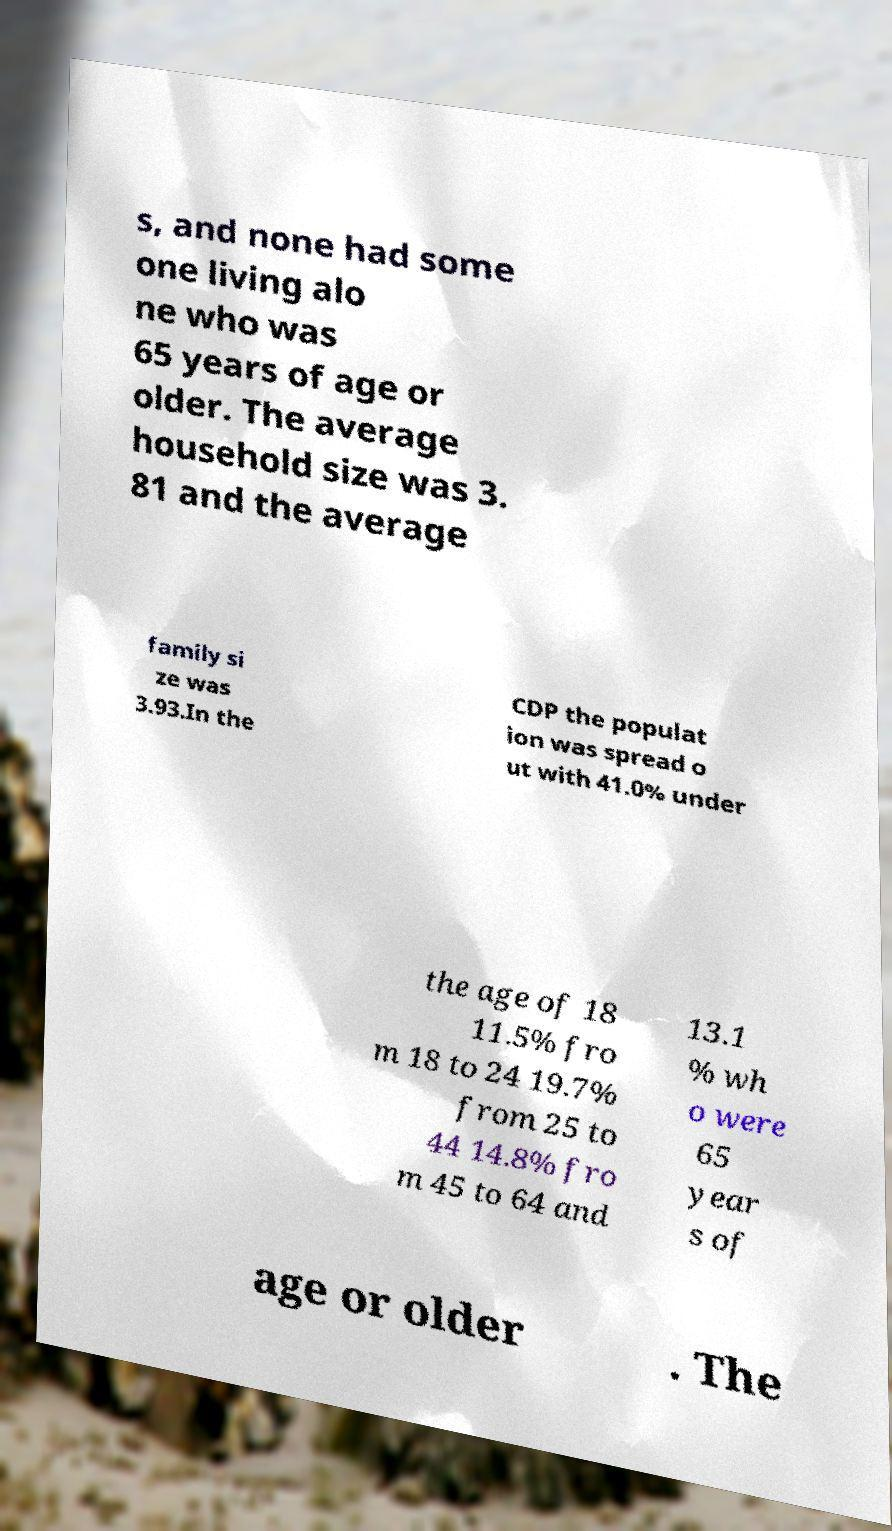Could you extract and type out the text from this image? s, and none had some one living alo ne who was 65 years of age or older. The average household size was 3. 81 and the average family si ze was 3.93.In the CDP the populat ion was spread o ut with 41.0% under the age of 18 11.5% fro m 18 to 24 19.7% from 25 to 44 14.8% fro m 45 to 64 and 13.1 % wh o were 65 year s of age or older . The 